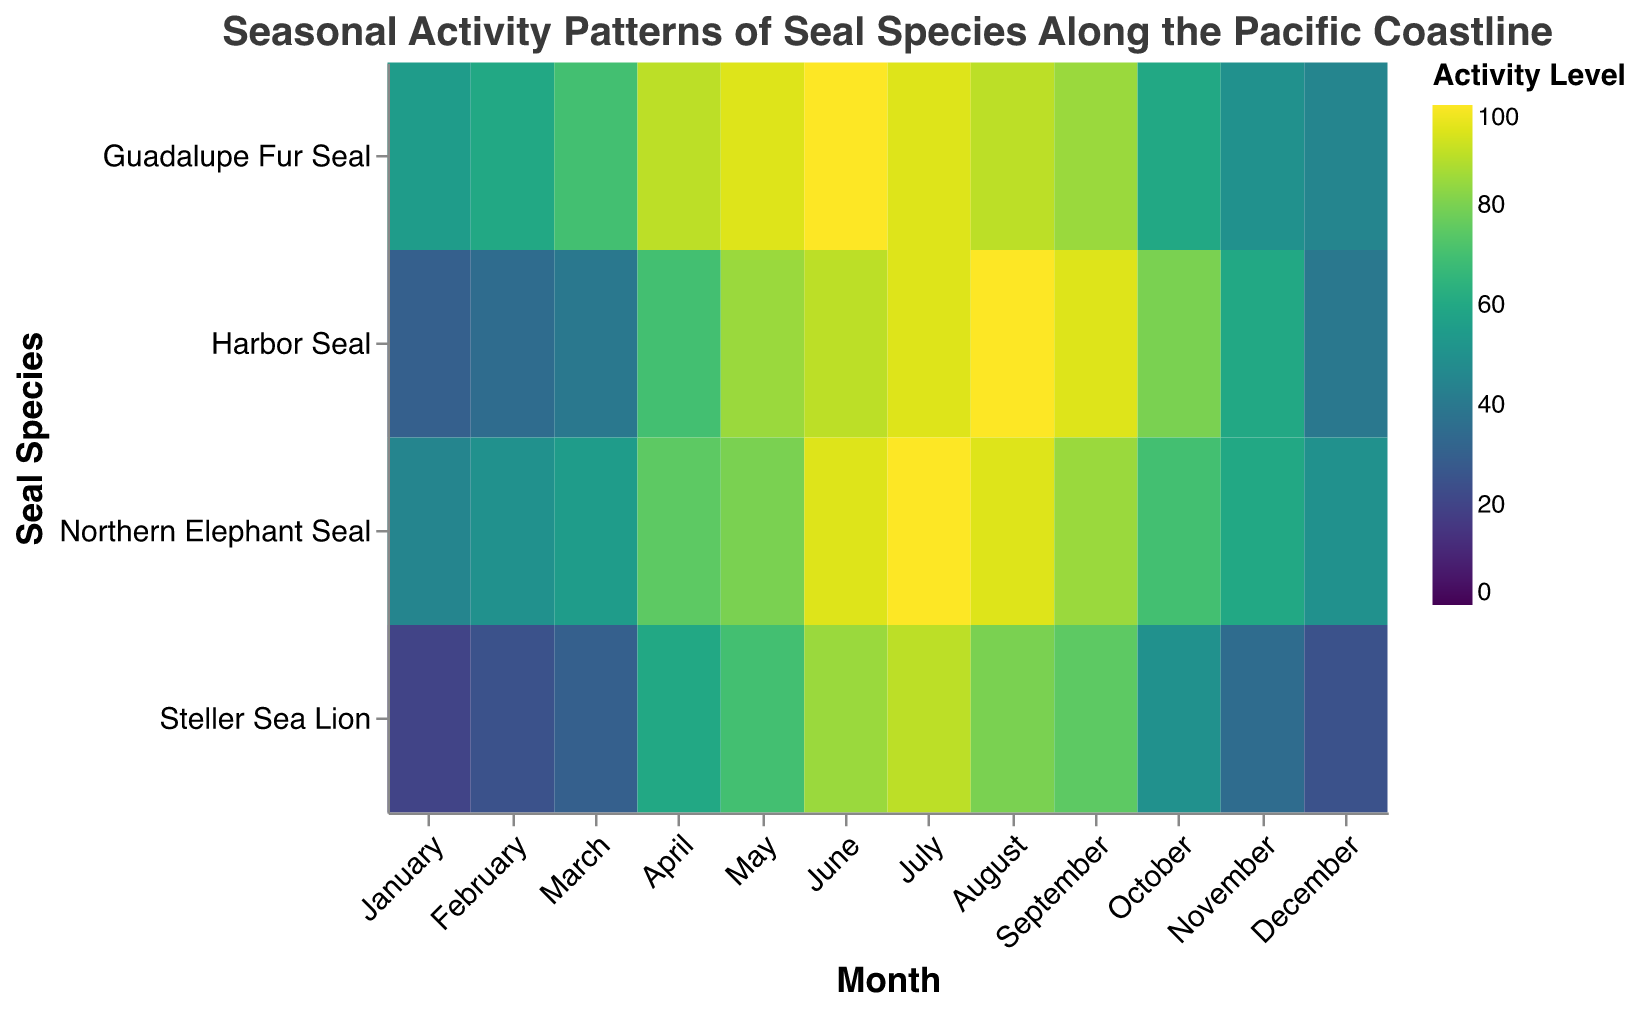What is the title of the heatmap? The title of the heatmap is located at the top of the chart and provides an overview of what the figure represents. Look at the text in bold or large font size.
Answer: Seasonal Activity Patterns of Seal Species Along the Pacific Coastline What months do Harbor Seals show their highest activity levels? To find this, look at the row corresponding to "Harbor Seal", and check which cells have the most intense color, indicating the highest activity levels.
Answer: July and August Which seal species shows the highest activity level in December? Compare the colors for each seal species in the "December" column. The species with the most intense color represents the highest activity level.
Answer: Northern Elephant Seal How does the activity level of Steller Sea Lion in April compare to May? Look at the colors of the cells corresponding to "Steller Sea Lion" in both April and May and compare their intensities.
Answer: Lower in April Which species has the most uniform activity level throughout the year? Observe the color variations across months for each species. The species with the least variance in color has the most uniform activity level.
Answer: Northern Elephant Seal During which month do all species exhibit relatively low activity levels? Find the month where the colors across all species are the least intense, indicating low activity levels.
Answer: January How does the activity pattern of the Guadalupe Fur Seal in July compare to June? Compare the color intensity for "Guadalupe Fur Seal" for the months of June and July.
Answer: Slightly lower in July What is the range of activity levels for the Northern Elephant Seal? Look at the highest and lowest color intensities in the "Northern Elephant Seal" row to find the maximum and minimum activity levels.
Answer: 45 to 100 Among the four species, which one shows the greatest increase in activity level from March to April? Examine the color changes from March to April for each species, identifying which species shows the largest difference in color intensity.
Answer: Harbor Seal How does the month of September compare in activity levels across all species? Compare the color intensities of each species in the month of September.
Answer: Relatively high across all species 